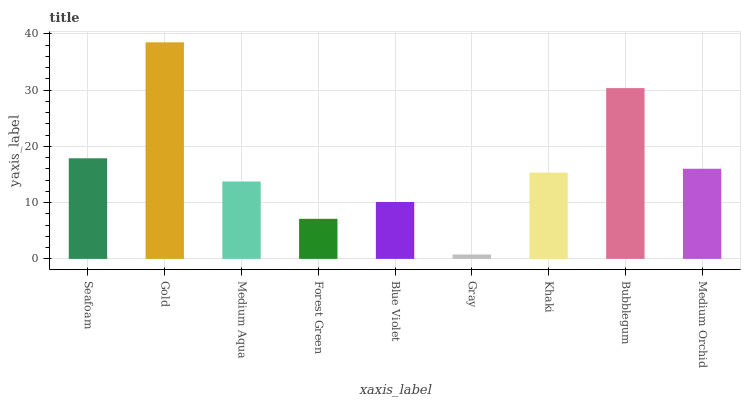Is Gray the minimum?
Answer yes or no. Yes. Is Gold the maximum?
Answer yes or no. Yes. Is Medium Aqua the minimum?
Answer yes or no. No. Is Medium Aqua the maximum?
Answer yes or no. No. Is Gold greater than Medium Aqua?
Answer yes or no. Yes. Is Medium Aqua less than Gold?
Answer yes or no. Yes. Is Medium Aqua greater than Gold?
Answer yes or no. No. Is Gold less than Medium Aqua?
Answer yes or no. No. Is Khaki the high median?
Answer yes or no. Yes. Is Khaki the low median?
Answer yes or no. Yes. Is Seafoam the high median?
Answer yes or no. No. Is Bubblegum the low median?
Answer yes or no. No. 